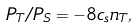Convert formula to latex. <formula><loc_0><loc_0><loc_500><loc_500>P _ { T } / P _ { S } = - 8 c _ { s } n _ { T } ,</formula> 